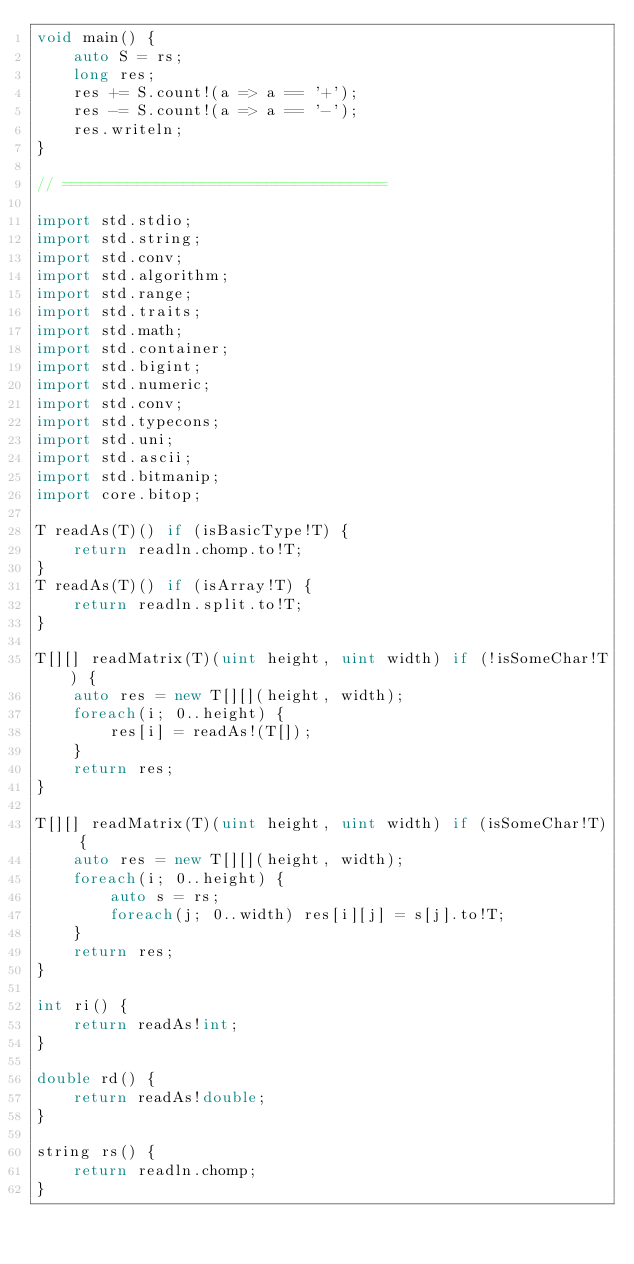Convert code to text. <code><loc_0><loc_0><loc_500><loc_500><_D_>void main() {
	auto S = rs;
	long res;
	res += S.count!(a => a == '+');
	res -= S.count!(a => a == '-');
	res.writeln;
}

// ===================================

import std.stdio;
import std.string;
import std.conv;
import std.algorithm;
import std.range;
import std.traits;
import std.math;
import std.container;
import std.bigint;
import std.numeric;
import std.conv;
import std.typecons;
import std.uni;
import std.ascii;
import std.bitmanip;
import core.bitop;

T readAs(T)() if (isBasicType!T) {
	return readln.chomp.to!T;
}
T readAs(T)() if (isArray!T) {
	return readln.split.to!T;
}

T[][] readMatrix(T)(uint height, uint width) if (!isSomeChar!T) {
	auto res = new T[][](height, width);
	foreach(i; 0..height) {
		res[i] = readAs!(T[]);
	}
	return res;
}

T[][] readMatrix(T)(uint height, uint width) if (isSomeChar!T) {
	auto res = new T[][](height, width);
	foreach(i; 0..height) {
		auto s = rs;
		foreach(j; 0..width) res[i][j] = s[j].to!T;
	}
	return res;
}

int ri() {
	return readAs!int;
}

double rd() {
	return readAs!double;
}

string rs() {
	return readln.chomp;
}</code> 